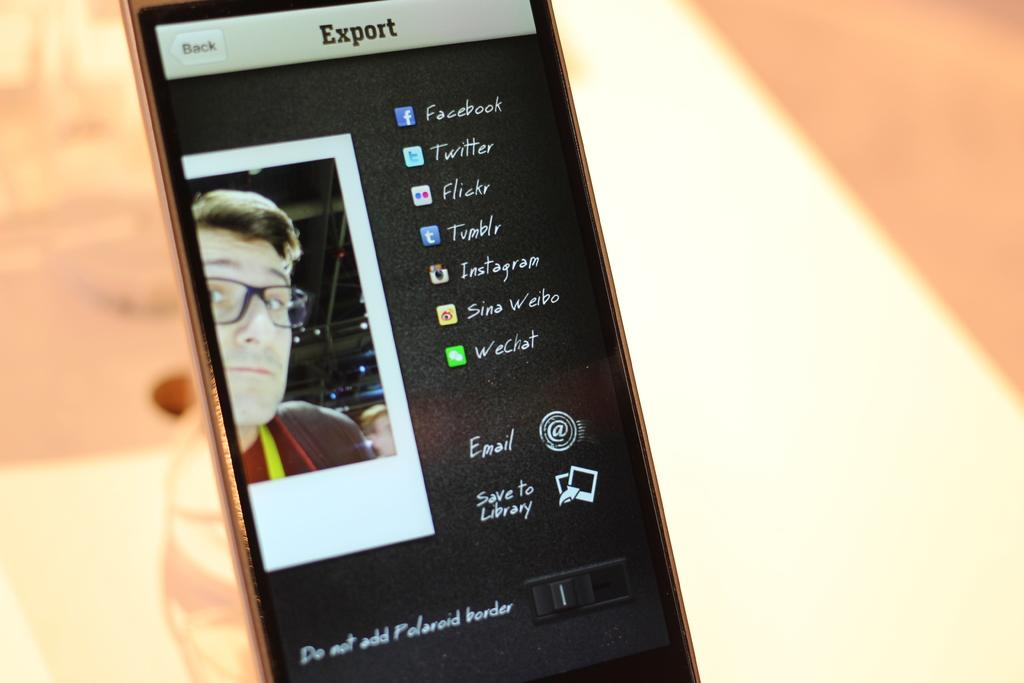<image>
Share a concise interpretation of the image provided. Export displaying the picture of a guy and the links to his social media 